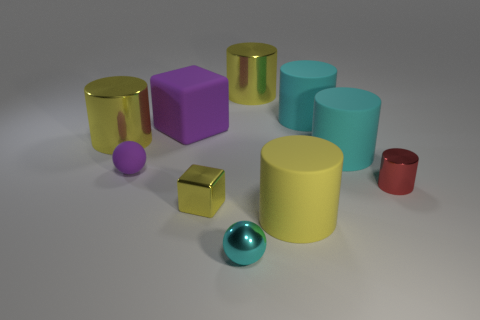How many yellow cylinders must be subtracted to get 1 yellow cylinders? 2 Subtract all cyan cubes. How many cyan cylinders are left? 2 Subtract all large cylinders. How many cylinders are left? 1 Subtract all purple balls. How many balls are left? 1 Subtract all spheres. How many objects are left? 8 Subtract all green spheres. Subtract all blue cylinders. How many spheres are left? 2 Subtract all small cyan matte cubes. Subtract all large cyan cylinders. How many objects are left? 8 Add 4 small yellow metal cubes. How many small yellow metal cubes are left? 5 Add 7 tiny rubber spheres. How many tiny rubber spheres exist? 8 Subtract 1 cyan balls. How many objects are left? 9 